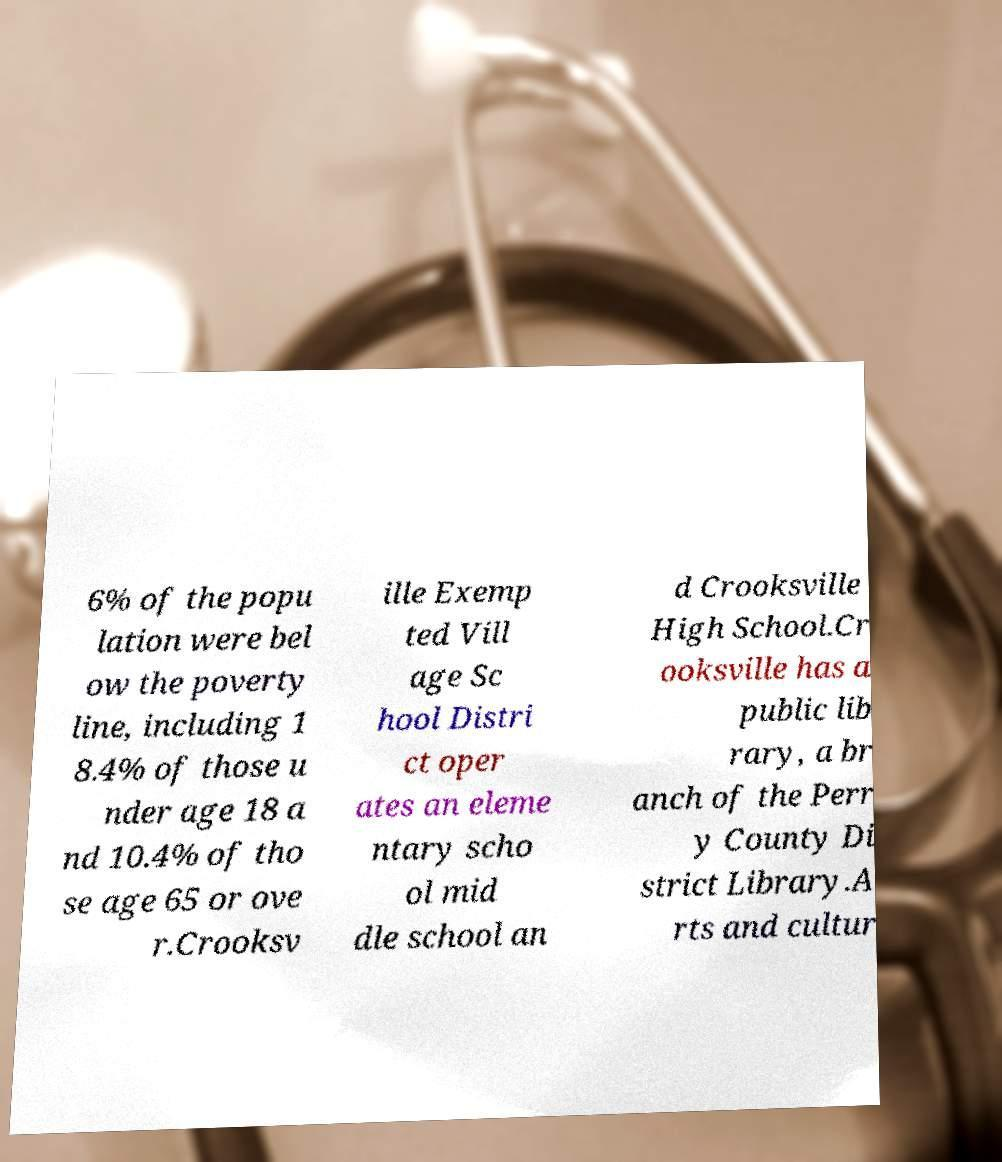Please identify and transcribe the text found in this image. 6% of the popu lation were bel ow the poverty line, including 1 8.4% of those u nder age 18 a nd 10.4% of tho se age 65 or ove r.Crooksv ille Exemp ted Vill age Sc hool Distri ct oper ates an eleme ntary scho ol mid dle school an d Crooksville High School.Cr ooksville has a public lib rary, a br anch of the Perr y County Di strict Library.A rts and cultur 